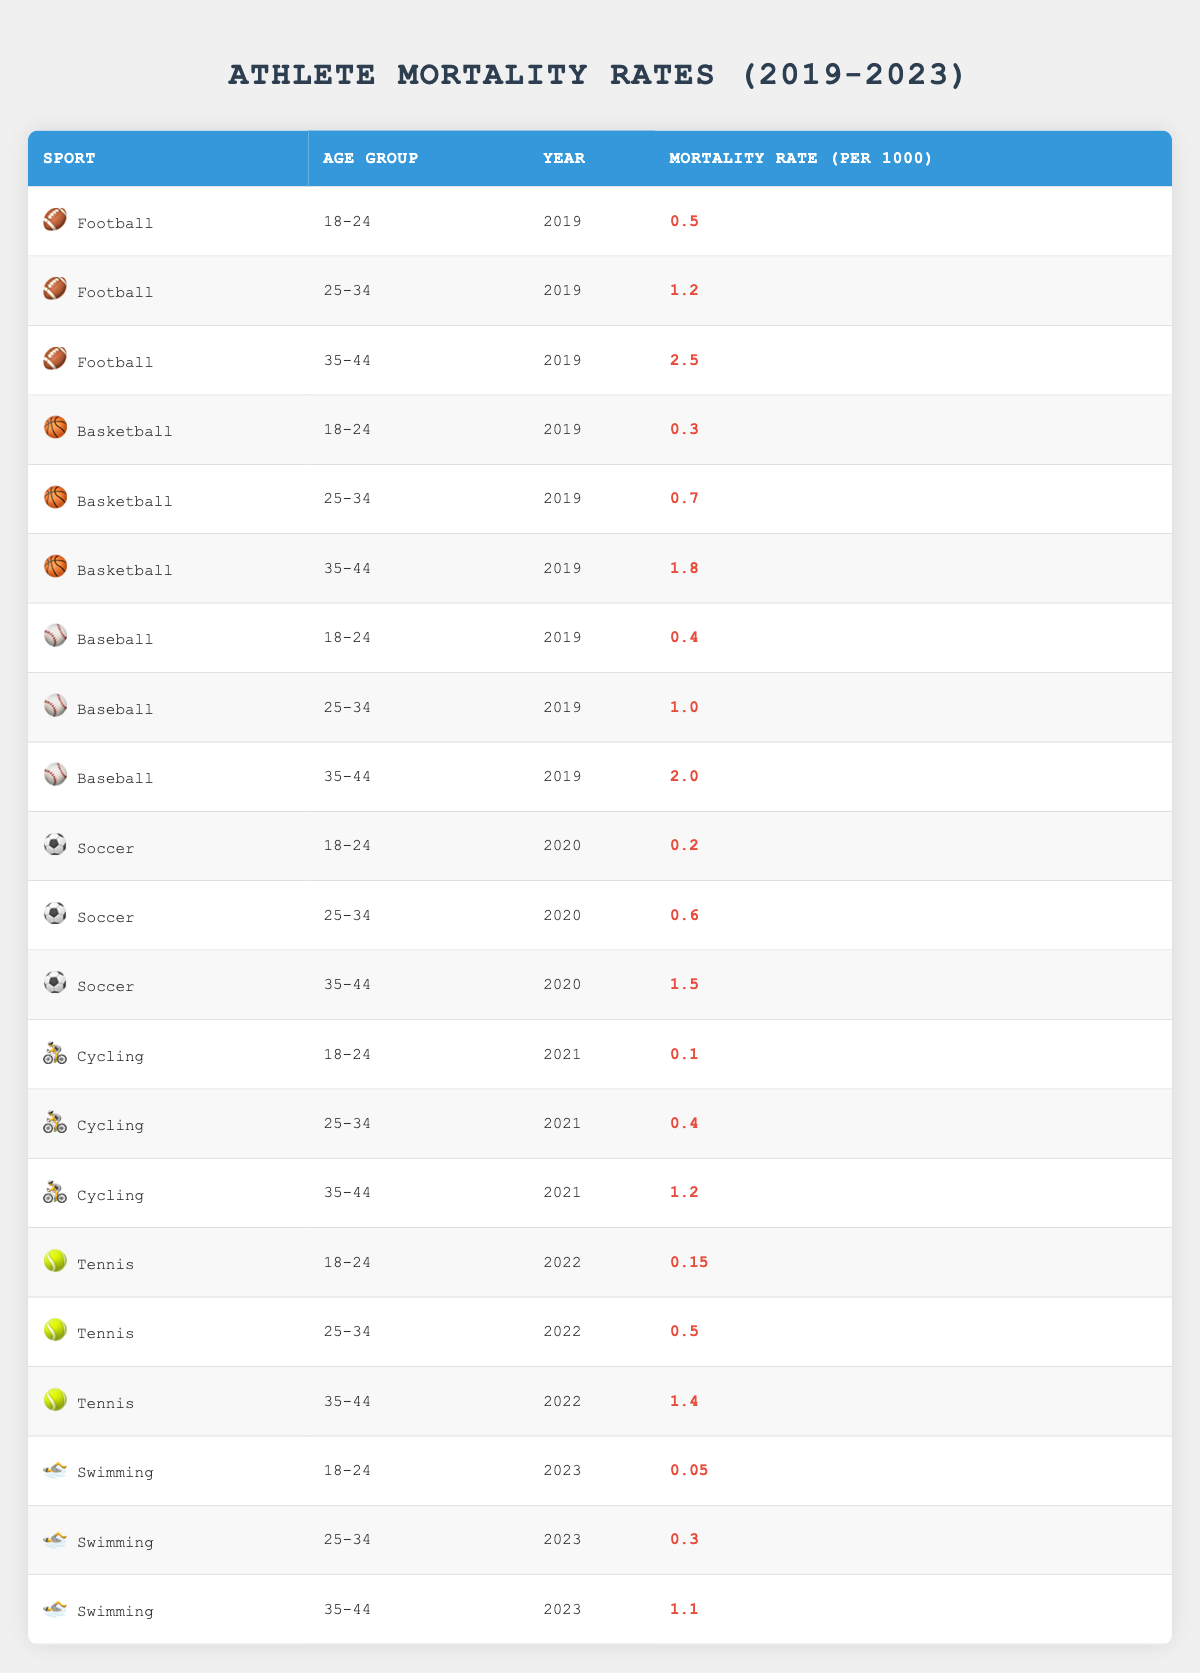What is the mortality rate for football athletes aged 25-34 in 2019? The table shows the row for football in the age group 25-34 for the year 2019, which indicates a mortality rate of 1.2 per 1000.
Answer: 1.2 What sport had the lowest mortality rate for athletes aged 18-24 in 2020? For the year 2020, the table lists soccer with a mortality rate of 0.2, which is lower than any other sport listed for that age group in that year.
Answer: Soccer Calculate the average mortality rate for basketball athletes aged 35-44 across all years. The mortality rates for basketball athletes aged 35-44 are 1.8 (2019), 1.5 (2020), and there are no entries beyond that for the years provided, so the average is (1.8 + 1.5) / 2 = 1.65.
Answer: 1.65 Was the mortality rate for cycling athletes aged 18-24 higher than for swimming athletes in the same age group in 2023? The table shows that cycling athletes aged 18-24 had a mortality rate of 0.1 in 2021, while swimming athletes aged 18-24 had a mortality rate of 0.05 in 2023. Since 0.1 > 0.05, the statement is true.
Answer: Yes What is the year when tennis athletes aged 25-34 had a mortality rate of 0.5? Referring to the table, it shows tennis athletes aged 25-34 had a mortality rate of 0.5 in the year 2022.
Answer: 2022 In what year did baseball athletes aged 35-44 have a mortality rate of 2.0? Looking at the table, baseball athletes aged 35-44 recorded a mortality rate of 2.0 in the year 2019.
Answer: 2019 Was the mortality rate for soccer athletes aged 25-34 higher than that for football athletes of the same age group in 2019? The table displays a mortality rate of 0.6 for soccer athletes aged 25-34 in 2020, and 1.2 for football athletes of the same age group in 2019, making the statement false as 0.6 < 1.2.
Answer: No Determine the difference in mortality rates between baseball and basketball athletes aged 25-34 in 2019. From the table, baseball had a mortality rate of 1.0 while basketball had a rate of 0.7 for the same age group in 2019. The difference is 1.0 - 0.7 = 0.3.
Answer: 0.3 What is the highest mortality rate recorded in the table and for which sport and age group? The highest mortality rate found in the table is 2.5 for football athletes aged 35-44 in 2019, making it the sport and age group combination associated with the highest mortality rate.
Answer: 2.5 for Football, 35-44 